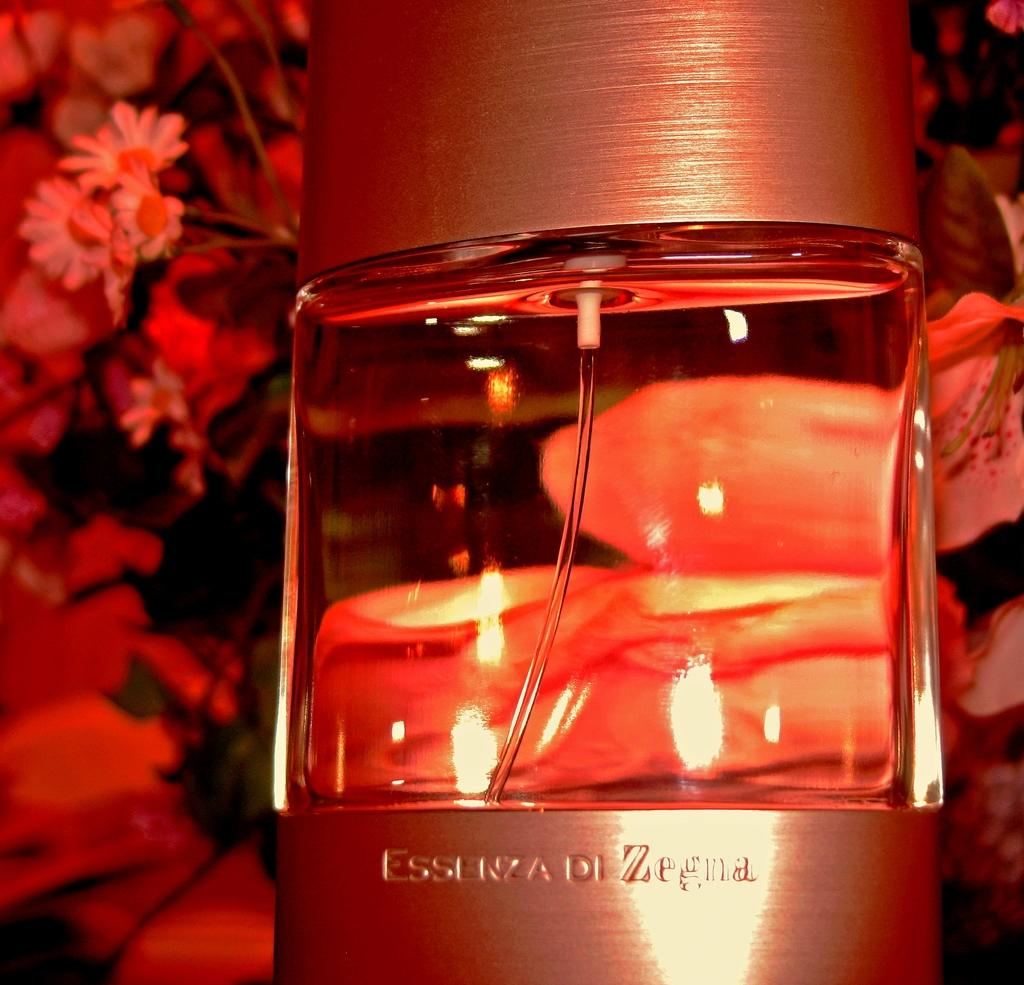<image>
Describe the image concisely. Half empty bottle of Essenza Di Zegna in front of a red background. 